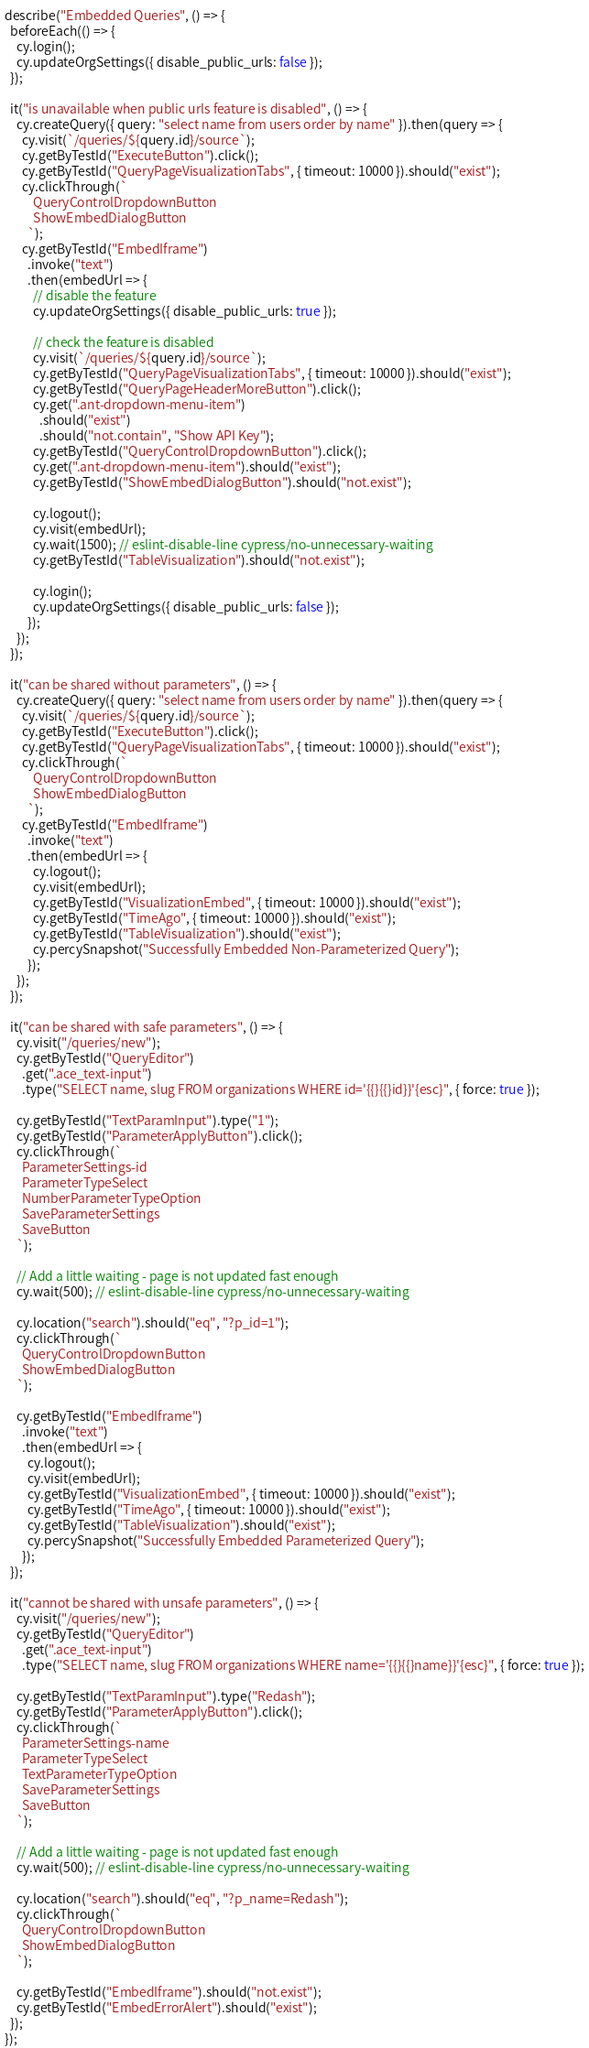Convert code to text. <code><loc_0><loc_0><loc_500><loc_500><_JavaScript_>describe("Embedded Queries", () => {
  beforeEach(() => {
    cy.login();
    cy.updateOrgSettings({ disable_public_urls: false });
  });

  it("is unavailable when public urls feature is disabled", () => {
    cy.createQuery({ query: "select name from users order by name" }).then(query => {
      cy.visit(`/queries/${query.id}/source`);
      cy.getByTestId("ExecuteButton").click();
      cy.getByTestId("QueryPageVisualizationTabs", { timeout: 10000 }).should("exist");
      cy.clickThrough(`
          QueryControlDropdownButton
          ShowEmbedDialogButton
        `);
      cy.getByTestId("EmbedIframe")
        .invoke("text")
        .then(embedUrl => {
          // disable the feature
          cy.updateOrgSettings({ disable_public_urls: true });

          // check the feature is disabled
          cy.visit(`/queries/${query.id}/source`);
          cy.getByTestId("QueryPageVisualizationTabs", { timeout: 10000 }).should("exist");
          cy.getByTestId("QueryPageHeaderMoreButton").click();
          cy.get(".ant-dropdown-menu-item")
            .should("exist")
            .should("not.contain", "Show API Key");
          cy.getByTestId("QueryControlDropdownButton").click();
          cy.get(".ant-dropdown-menu-item").should("exist");
          cy.getByTestId("ShowEmbedDialogButton").should("not.exist");

          cy.logout();
          cy.visit(embedUrl);
          cy.wait(1500); // eslint-disable-line cypress/no-unnecessary-waiting
          cy.getByTestId("TableVisualization").should("not.exist");

          cy.login();
          cy.updateOrgSettings({ disable_public_urls: false });
        });
    });
  });

  it("can be shared without parameters", () => {
    cy.createQuery({ query: "select name from users order by name" }).then(query => {
      cy.visit(`/queries/${query.id}/source`);
      cy.getByTestId("ExecuteButton").click();
      cy.getByTestId("QueryPageVisualizationTabs", { timeout: 10000 }).should("exist");
      cy.clickThrough(`
          QueryControlDropdownButton
          ShowEmbedDialogButton
        `);
      cy.getByTestId("EmbedIframe")
        .invoke("text")
        .then(embedUrl => {
          cy.logout();
          cy.visit(embedUrl);
          cy.getByTestId("VisualizationEmbed", { timeout: 10000 }).should("exist");
          cy.getByTestId("TimeAgo", { timeout: 10000 }).should("exist");
          cy.getByTestId("TableVisualization").should("exist");
          cy.percySnapshot("Successfully Embedded Non-Parameterized Query");
        });
    });
  });

  it("can be shared with safe parameters", () => {
    cy.visit("/queries/new");
    cy.getByTestId("QueryEditor")
      .get(".ace_text-input")
      .type("SELECT name, slug FROM organizations WHERE id='{{}{{}id}}'{esc}", { force: true });

    cy.getByTestId("TextParamInput").type("1");
    cy.getByTestId("ParameterApplyButton").click();
    cy.clickThrough(`
      ParameterSettings-id
      ParameterTypeSelect
      NumberParameterTypeOption
      SaveParameterSettings
      SaveButton
    `);

    // Add a little waiting - page is not updated fast enough
    cy.wait(500); // eslint-disable-line cypress/no-unnecessary-waiting

    cy.location("search").should("eq", "?p_id=1");
    cy.clickThrough(`
      QueryControlDropdownButton
      ShowEmbedDialogButton
    `);

    cy.getByTestId("EmbedIframe")
      .invoke("text")
      .then(embedUrl => {
        cy.logout();
        cy.visit(embedUrl);
        cy.getByTestId("VisualizationEmbed", { timeout: 10000 }).should("exist");
        cy.getByTestId("TimeAgo", { timeout: 10000 }).should("exist");
        cy.getByTestId("TableVisualization").should("exist");
        cy.percySnapshot("Successfully Embedded Parameterized Query");
      });
  });

  it("cannot be shared with unsafe parameters", () => {
    cy.visit("/queries/new");
    cy.getByTestId("QueryEditor")
      .get(".ace_text-input")
      .type("SELECT name, slug FROM organizations WHERE name='{{}{{}name}}'{esc}", { force: true });

    cy.getByTestId("TextParamInput").type("Redash");
    cy.getByTestId("ParameterApplyButton").click();
    cy.clickThrough(`
      ParameterSettings-name
      ParameterTypeSelect
      TextParameterTypeOption
      SaveParameterSettings
      SaveButton
    `);

    // Add a little waiting - page is not updated fast enough
    cy.wait(500); // eslint-disable-line cypress/no-unnecessary-waiting

    cy.location("search").should("eq", "?p_name=Redash");
    cy.clickThrough(`
      QueryControlDropdownButton
      ShowEmbedDialogButton
    `);

    cy.getByTestId("EmbedIframe").should("not.exist");
    cy.getByTestId("EmbedErrorAlert").should("exist");
  });
});
</code> 